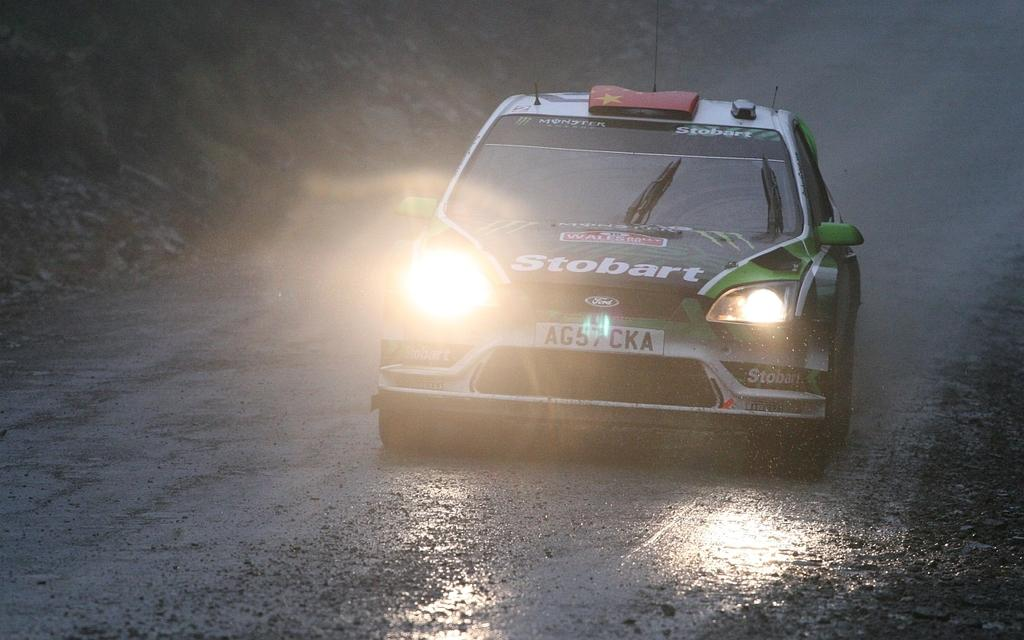What is the main subject of the image? The main subject of the image is a car. Where is the car located in the image? The car is on a road in the image. How is the car positioned in the image? The car is in the center of the image. What types of pets can be seen playing in the car during the afternoon? There are no pets visible in the image, and the time of day is not mentioned, so it cannot be determined if the car is being used during the afternoon or if any pets are present. 